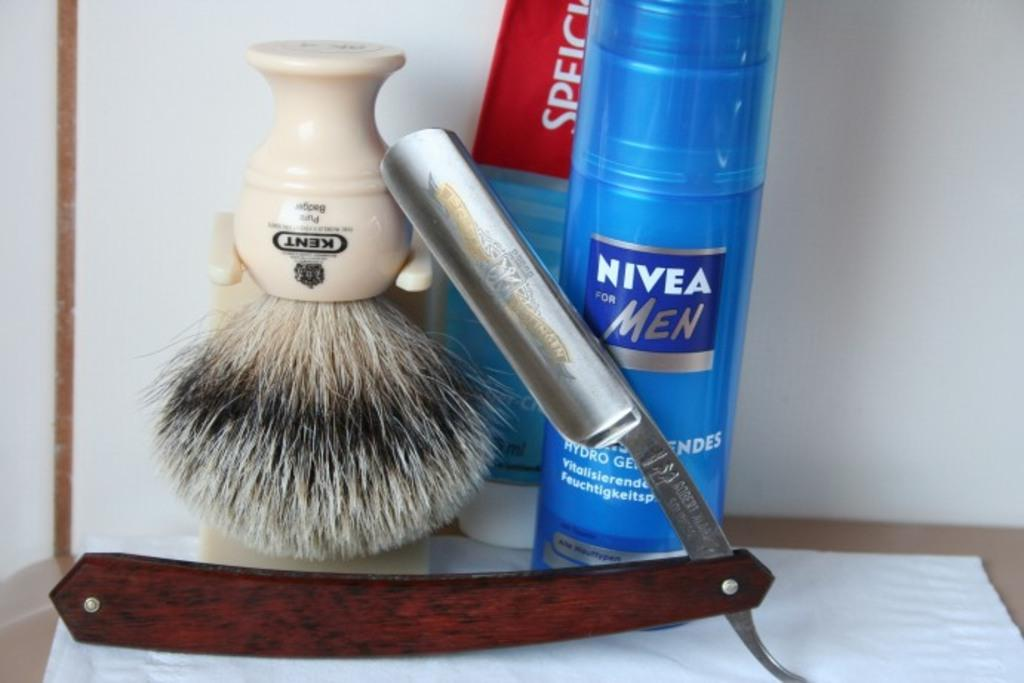<image>
Give a short and clear explanation of the subsequent image. A large blue bottle of Nivea for Men sits behind a safety razor. 